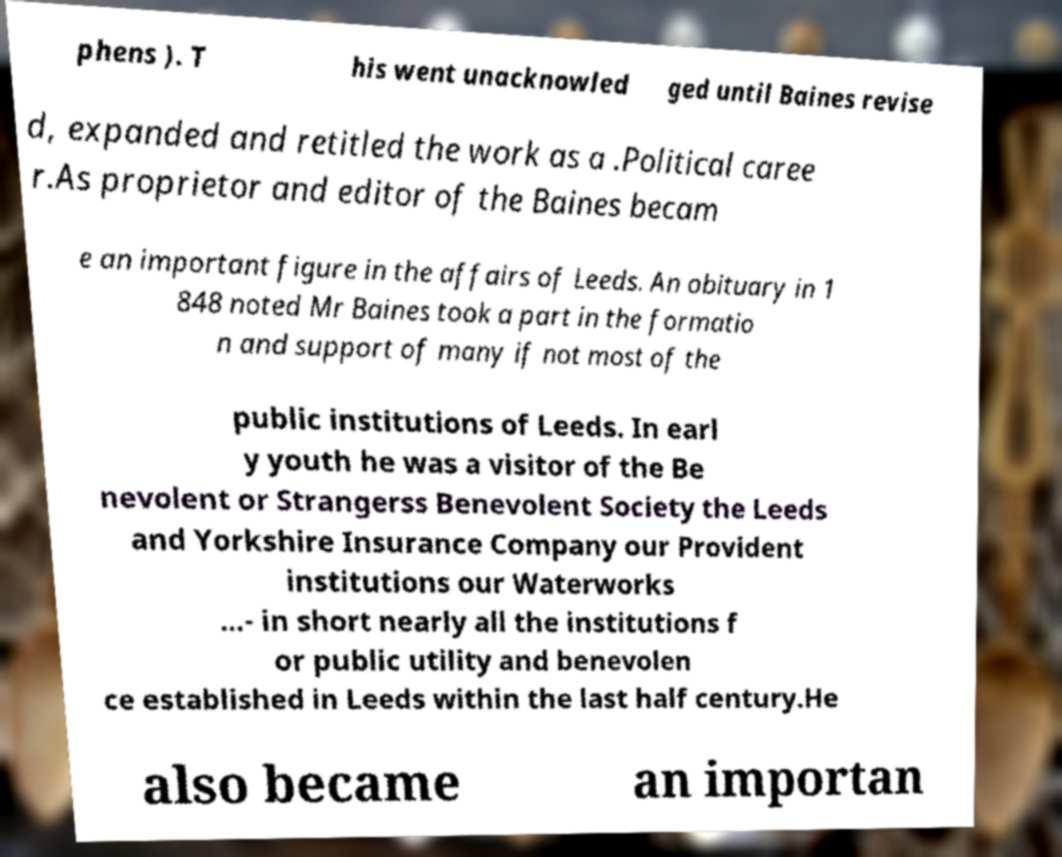Please read and relay the text visible in this image. What does it say? phens ). T his went unacknowled ged until Baines revise d, expanded and retitled the work as a .Political caree r.As proprietor and editor of the Baines becam e an important figure in the affairs of Leeds. An obituary in 1 848 noted Mr Baines took a part in the formatio n and support of many if not most of the public institutions of Leeds. In earl y youth he was a visitor of the Be nevolent or Strangerss Benevolent Society the Leeds and Yorkshire Insurance Company our Provident institutions our Waterworks …- in short nearly all the institutions f or public utility and benevolen ce established in Leeds within the last half century.He also became an importan 